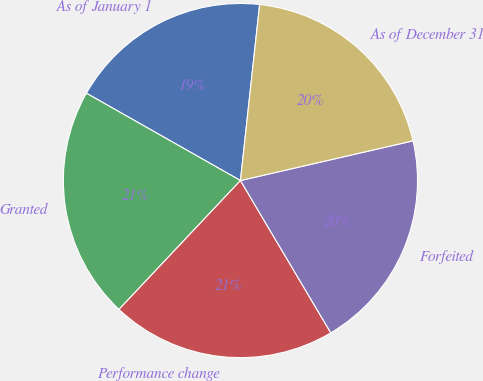Convert chart to OTSL. <chart><loc_0><loc_0><loc_500><loc_500><pie_chart><fcel>As of January 1<fcel>Granted<fcel>Performance change<fcel>Forfeited<fcel>As of December 31<nl><fcel>18.52%<fcel>21.18%<fcel>20.55%<fcel>20.08%<fcel>19.67%<nl></chart> 